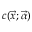Convert formula to latex. <formula><loc_0><loc_0><loc_500><loc_500>c ( \vec { x } ; \vec { \alpha } )</formula> 